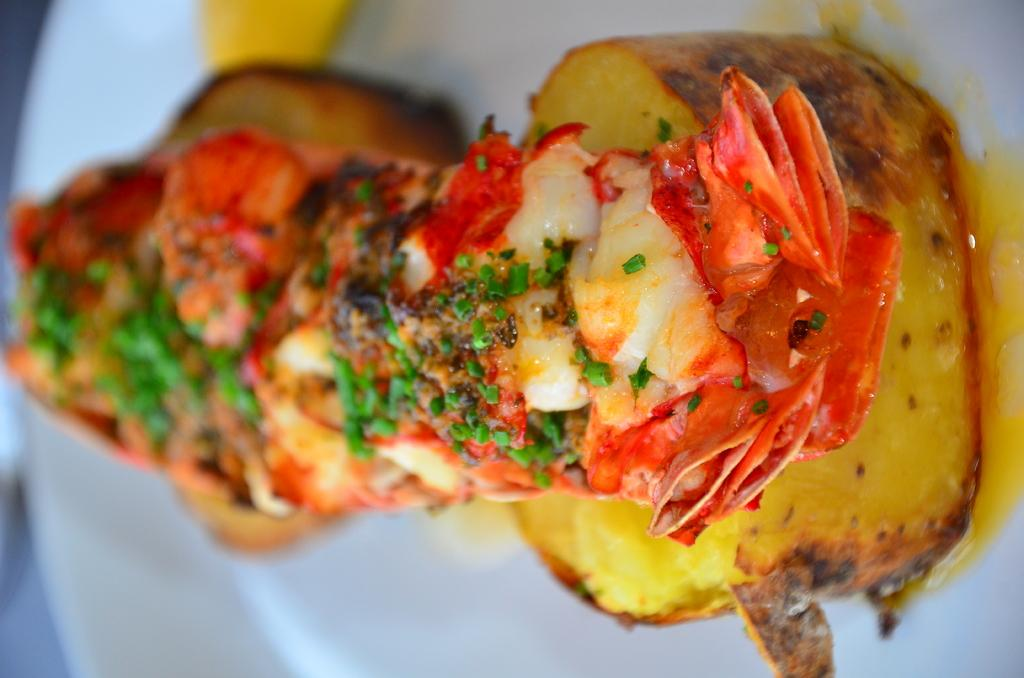What is the main subject of the image? There is a food item on a plate in the image. Can you describe the background of the image? The background of the image is blurred. What type of ornament is hanging from the ceiling in the image? There is no ornament hanging from the ceiling in the image; it only features a food item on a plate and a blurred background. Can you tell me how many pets are visible in the image? There are no pets present in the image. 